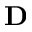Convert formula to latex. <formula><loc_0><loc_0><loc_500><loc_500>D</formula> 